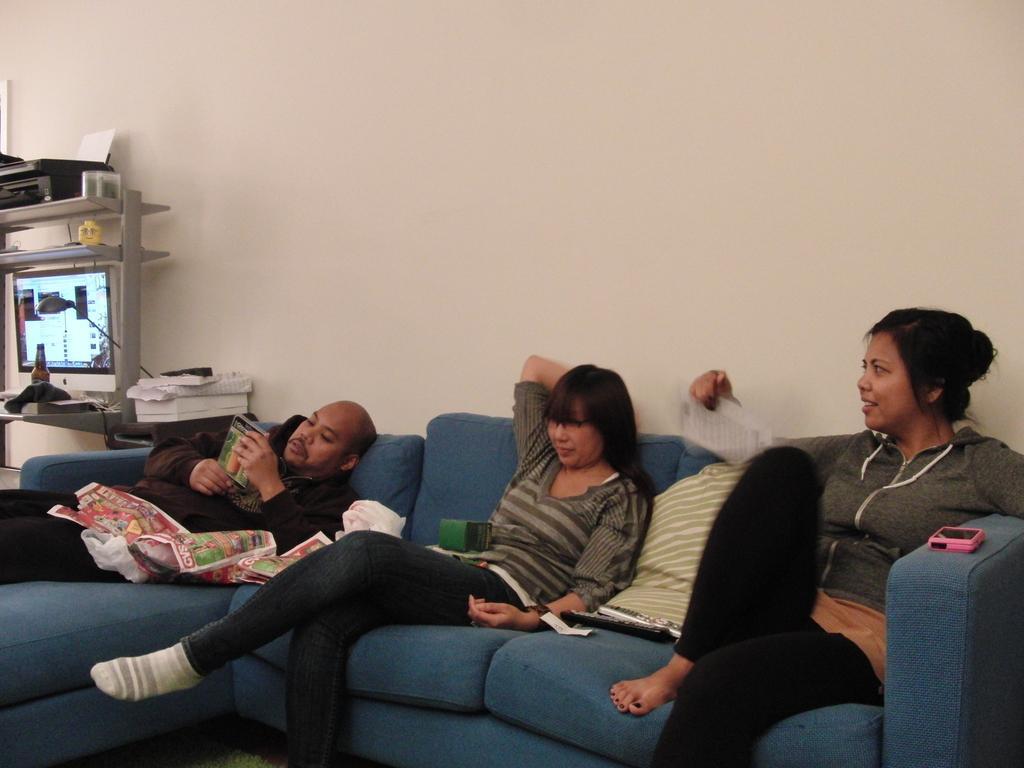Could you give a brief overview of what you see in this image? In this image I can see three people where two of them are sitting on a sofa and one is lying on it. In the background I can see a screen and a bottle. 